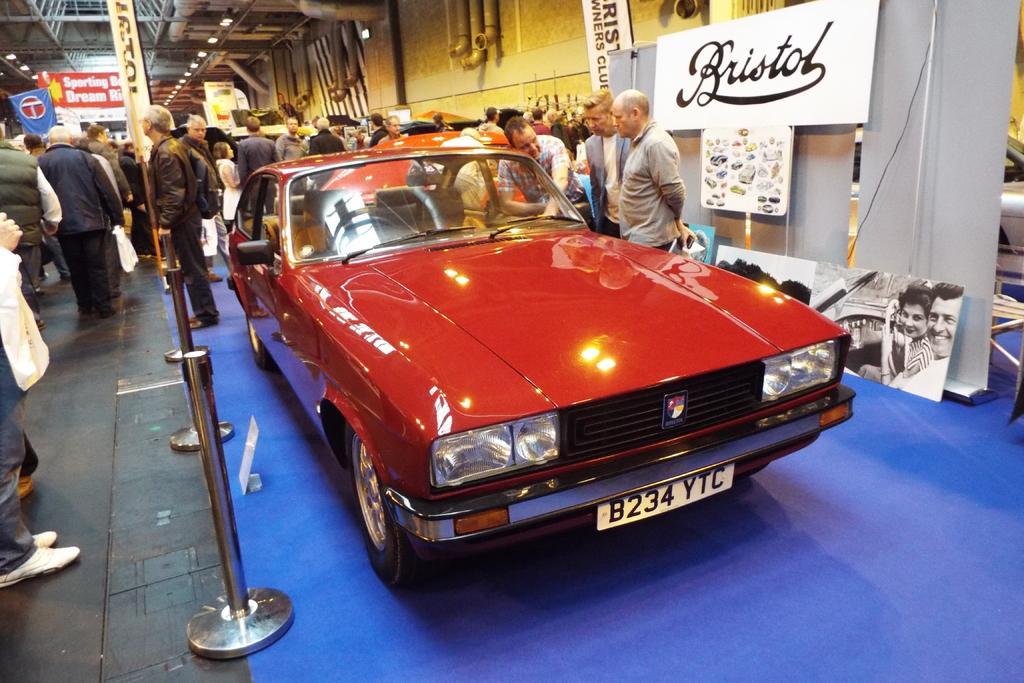Could you give a brief overview of what you see in this image? The picture is taken inside a big room where many people are standing and walking and at the right corner there is one red colour car and behind that there are people standing and there is one white cloth and some name boards are placed on it and there are pipelines attached to the wall. 